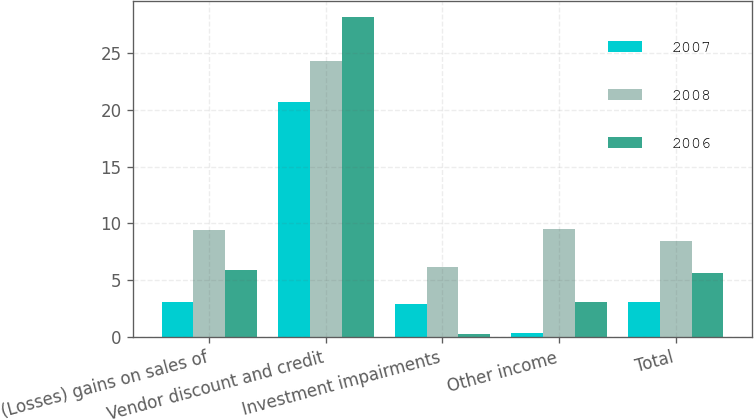Convert chart. <chart><loc_0><loc_0><loc_500><loc_500><stacked_bar_chart><ecel><fcel>(Losses) gains on sales of<fcel>Vendor discount and credit<fcel>Investment impairments<fcel>Other income<fcel>Total<nl><fcel>2007<fcel>3.1<fcel>20.7<fcel>2.9<fcel>0.4<fcel>3.1<nl><fcel>2008<fcel>9.4<fcel>24.3<fcel>6.2<fcel>9.5<fcel>8.5<nl><fcel>2006<fcel>5.9<fcel>28.2<fcel>0.3<fcel>3.1<fcel>5.6<nl></chart> 